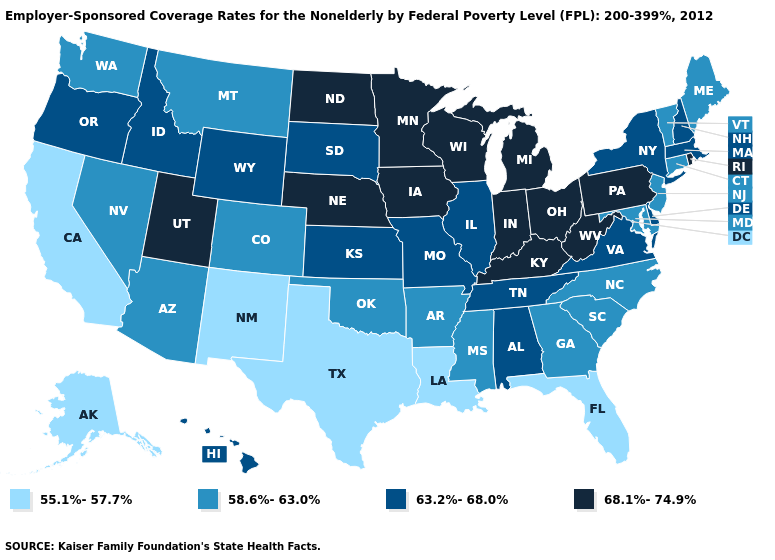Which states have the lowest value in the Northeast?
Short answer required. Connecticut, Maine, New Jersey, Vermont. Does Indiana have the highest value in the USA?
Keep it brief. Yes. Among the states that border Colorado , which have the lowest value?
Keep it brief. New Mexico. What is the value of Alabama?
Short answer required. 63.2%-68.0%. What is the value of Washington?
Answer briefly. 58.6%-63.0%. What is the value of Alaska?
Quick response, please. 55.1%-57.7%. What is the value of West Virginia?
Answer briefly. 68.1%-74.9%. How many symbols are there in the legend?
Quick response, please. 4. Does Nebraska have a lower value than New Hampshire?
Give a very brief answer. No. How many symbols are there in the legend?
Answer briefly. 4. What is the highest value in the West ?
Give a very brief answer. 68.1%-74.9%. Does New Hampshire have the lowest value in the Northeast?
Short answer required. No. Which states have the lowest value in the West?
Short answer required. Alaska, California, New Mexico. Name the states that have a value in the range 68.1%-74.9%?
Be succinct. Indiana, Iowa, Kentucky, Michigan, Minnesota, Nebraska, North Dakota, Ohio, Pennsylvania, Rhode Island, Utah, West Virginia, Wisconsin. What is the value of Maryland?
Keep it brief. 58.6%-63.0%. 